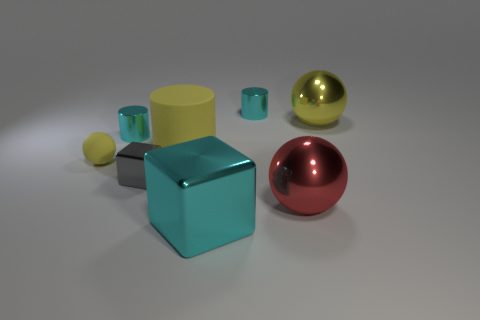Subtract all cyan cylinders. How many were subtracted if there are1cyan cylinders left? 1 Add 2 cyan cylinders. How many objects exist? 10 Subtract all blocks. How many objects are left? 6 Add 7 yellow objects. How many yellow objects exist? 10 Subtract 0 purple cylinders. How many objects are left? 8 Subtract all cyan rubber balls. Subtract all large cyan cubes. How many objects are left? 7 Add 5 yellow matte cylinders. How many yellow matte cylinders are left? 6 